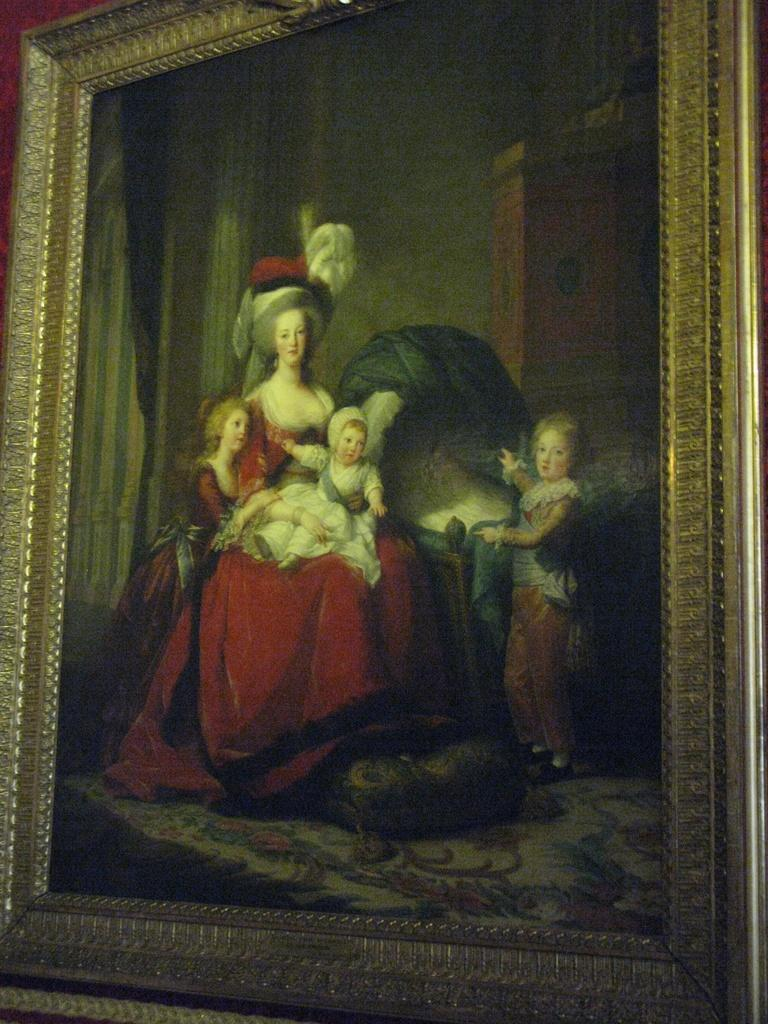What is the main subject of the image? The main subject of the image is a photo frame of a frame of a painting. What is depicted in the painting? The painting depicts three kids and a lady. What is the lady wearing in the painting? The lady is wearing a red dress in the painting. What is the lady's position in the painting? The lady is sitting on a chair in the painting. What type of cloth is being used to clean the teeth in the image? There is no cloth or teeth present in the image; it features a photo frame of a painting depicting three kids and a lady. 